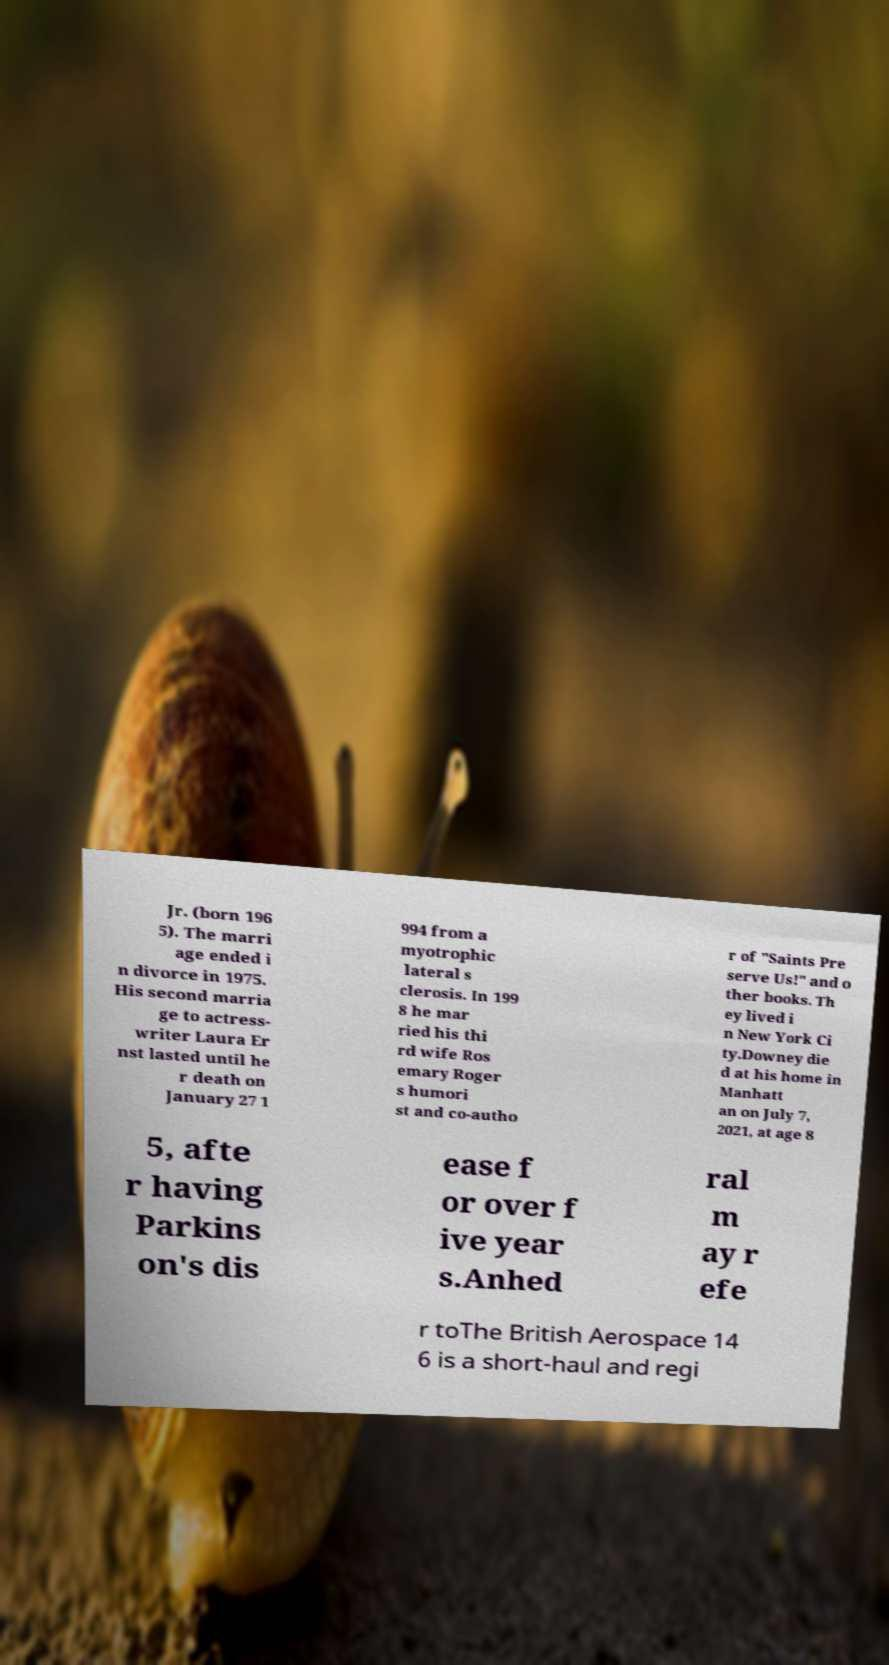Could you extract and type out the text from this image? Jr. (born 196 5). The marri age ended i n divorce in 1975. His second marria ge to actress- writer Laura Er nst lasted until he r death on January 27 1 994 from a myotrophic lateral s clerosis. In 199 8 he mar ried his thi rd wife Ros emary Roger s humori st and co-autho r of "Saints Pre serve Us!" and o ther books. Th ey lived i n New York Ci ty.Downey die d at his home in Manhatt an on July 7, 2021, at age 8 5, afte r having Parkins on's dis ease f or over f ive year s.Anhed ral m ay r efe r toThe British Aerospace 14 6 is a short-haul and regi 